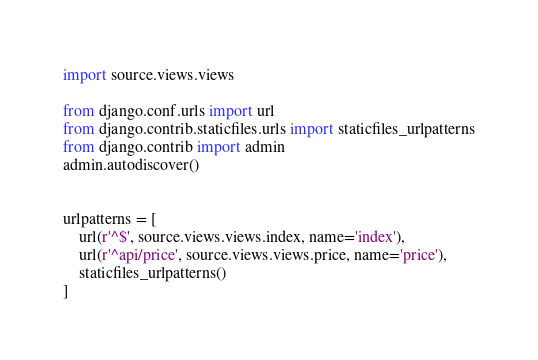<code> <loc_0><loc_0><loc_500><loc_500><_Python_>import source.views.views

from django.conf.urls import url
from django.contrib.staticfiles.urls import staticfiles_urlpatterns
from django.contrib import admin
admin.autodiscover()


urlpatterns = [
    url(r'^$', source.views.views.index, name='index'),
    url(r'^api/price', source.views.views.price, name='price'),
    staticfiles_urlpatterns()
]
</code> 